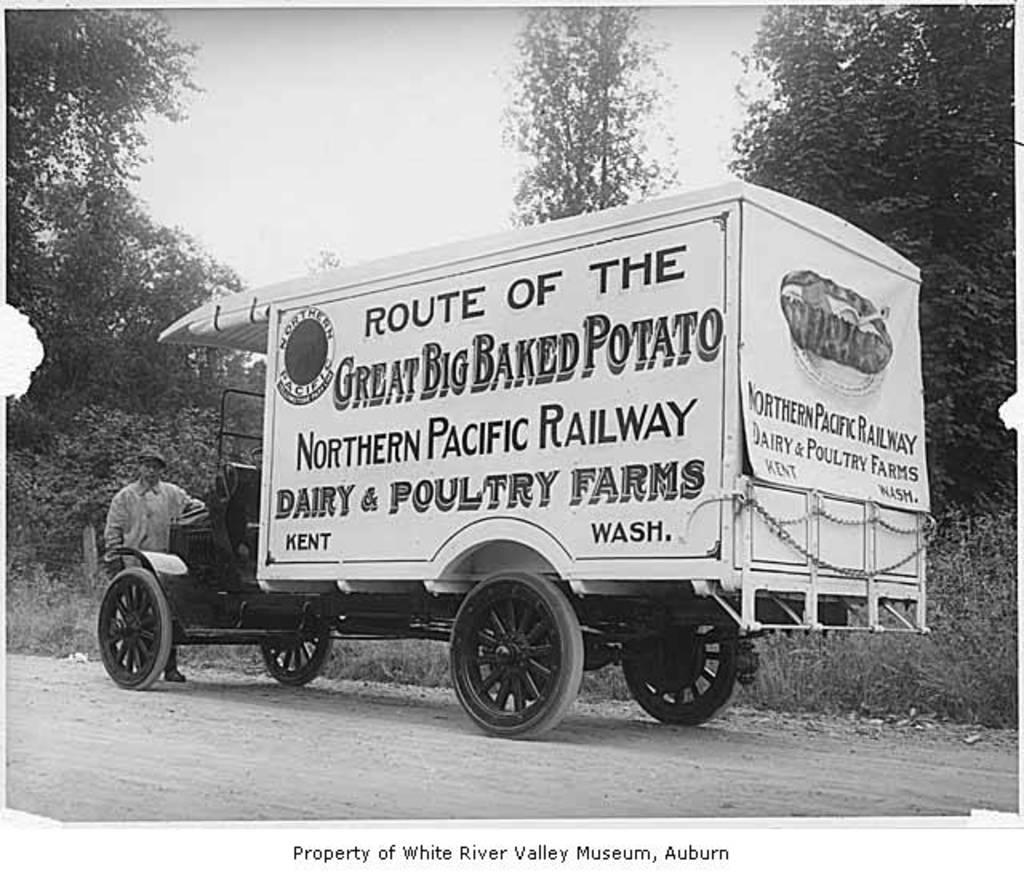What is the main subject in the foreground of the image? There is a vehicle on the road in the foreground of the image. What is the man in the image doing? The man is standing in front of the vehicle. What is the color scheme of the image? The image is in black and white. What can be seen in the background of the image? There are trees and the sky visible in the background of the image. Can you see any steam coming from the vehicle in the image? There is no steam visible in the image. What type of airport is shown in the background of the image? There is no airport present in the image; it features a vehicle on the road, a man, trees, and the sky. 